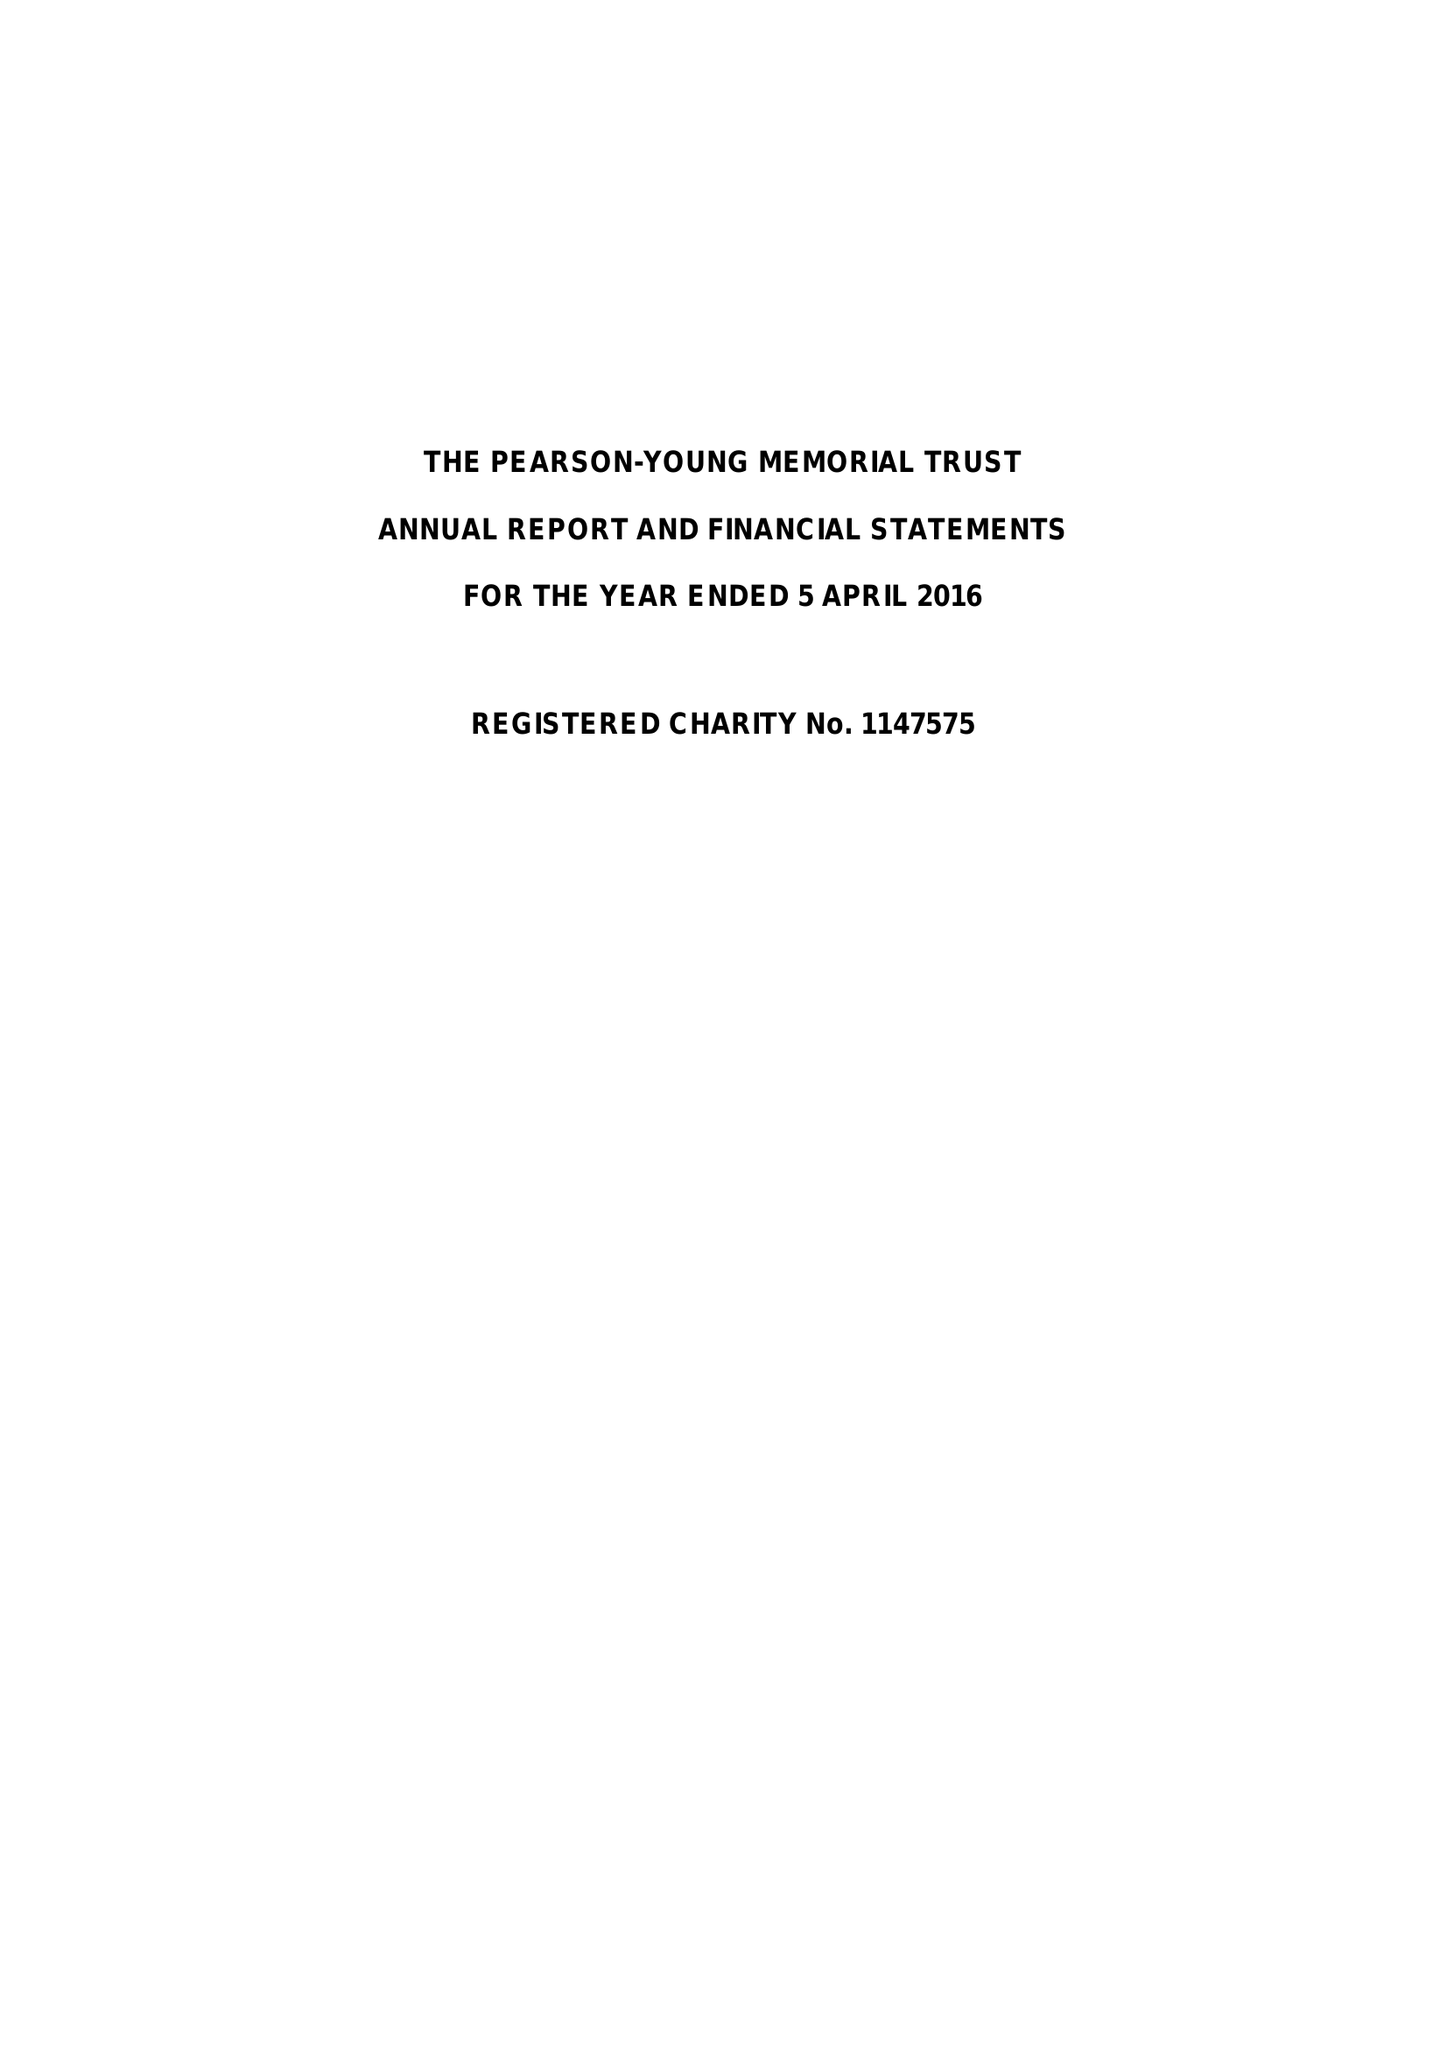What is the value for the address__postcode?
Answer the question using a single word or phrase. SW1H 0BL 